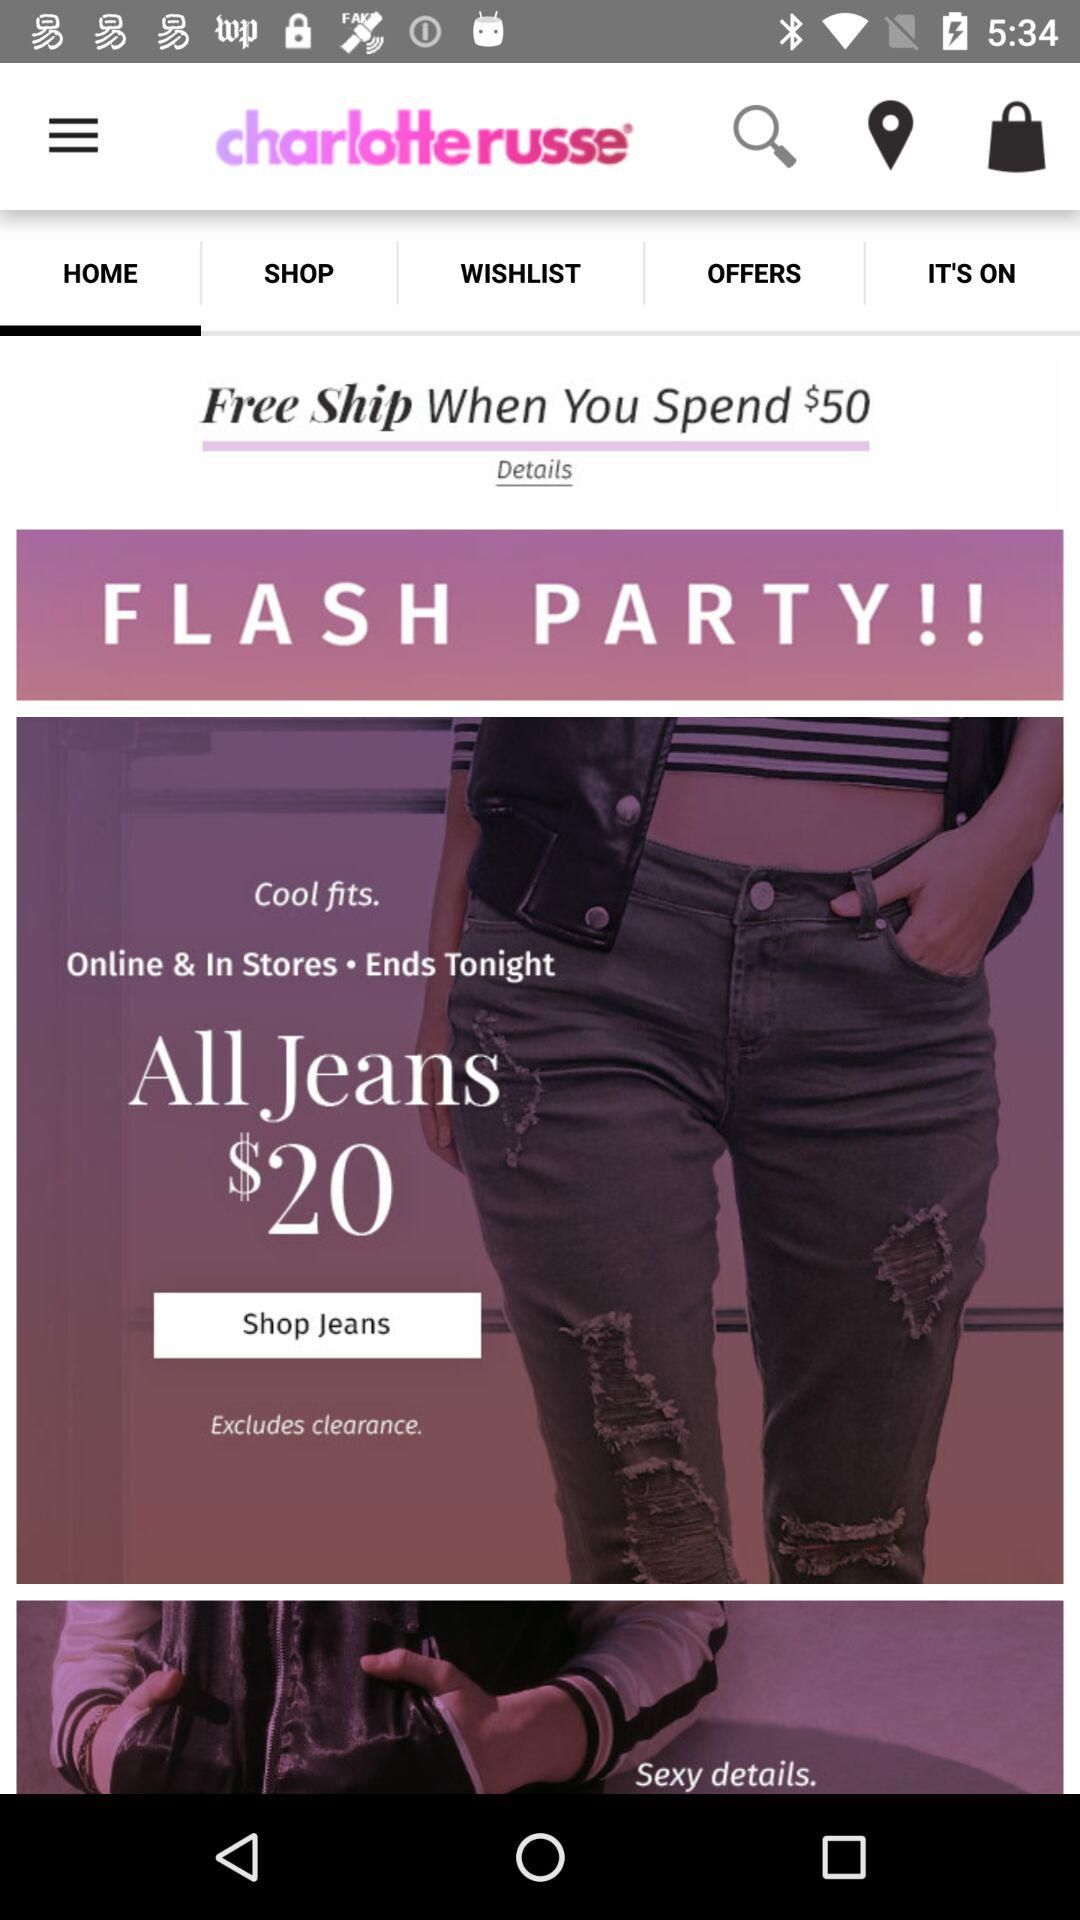What is the price of all jeans? The price of all jeans is $20. 